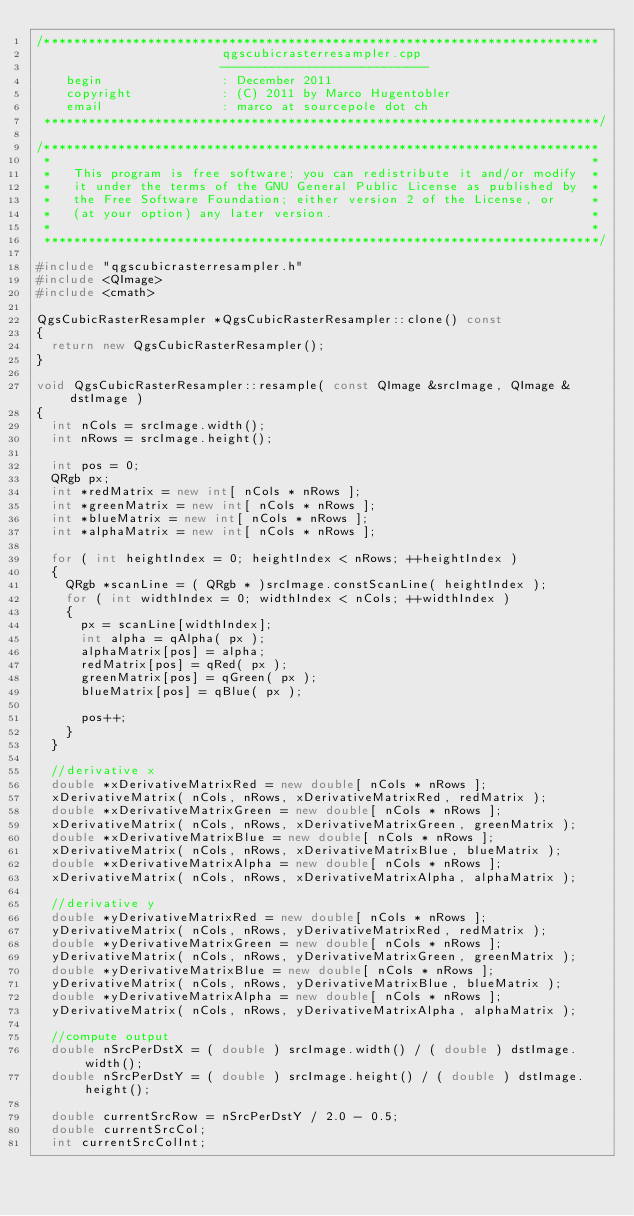Convert code to text. <code><loc_0><loc_0><loc_500><loc_500><_C++_>/***************************************************************************
                         qgscubicrasterresampler.cpp
                         ----------------------------
    begin                : December 2011
    copyright            : (C) 2011 by Marco Hugentobler
    email                : marco at sourcepole dot ch
 ***************************************************************************/

/***************************************************************************
 *                                                                         *
 *   This program is free software; you can redistribute it and/or modify  *
 *   it under the terms of the GNU General Public License as published by  *
 *   the Free Software Foundation; either version 2 of the License, or     *
 *   (at your option) any later version.                                   *
 *                                                                         *
 ***************************************************************************/

#include "qgscubicrasterresampler.h"
#include <QImage>
#include <cmath>

QgsCubicRasterResampler *QgsCubicRasterResampler::clone() const
{
  return new QgsCubicRasterResampler();
}

void QgsCubicRasterResampler::resample( const QImage &srcImage, QImage &dstImage )
{
  int nCols = srcImage.width();
  int nRows = srcImage.height();

  int pos = 0;
  QRgb px;
  int *redMatrix = new int[ nCols * nRows ];
  int *greenMatrix = new int[ nCols * nRows ];
  int *blueMatrix = new int[ nCols * nRows ];
  int *alphaMatrix = new int[ nCols * nRows ];

  for ( int heightIndex = 0; heightIndex < nRows; ++heightIndex )
  {
    QRgb *scanLine = ( QRgb * )srcImage.constScanLine( heightIndex );
    for ( int widthIndex = 0; widthIndex < nCols; ++widthIndex )
    {
      px = scanLine[widthIndex];
      int alpha = qAlpha( px );
      alphaMatrix[pos] = alpha;
      redMatrix[pos] = qRed( px );
      greenMatrix[pos] = qGreen( px );
      blueMatrix[pos] = qBlue( px );

      pos++;
    }
  }

  //derivative x
  double *xDerivativeMatrixRed = new double[ nCols * nRows ];
  xDerivativeMatrix( nCols, nRows, xDerivativeMatrixRed, redMatrix );
  double *xDerivativeMatrixGreen = new double[ nCols * nRows ];
  xDerivativeMatrix( nCols, nRows, xDerivativeMatrixGreen, greenMatrix );
  double *xDerivativeMatrixBlue = new double[ nCols * nRows ];
  xDerivativeMatrix( nCols, nRows, xDerivativeMatrixBlue, blueMatrix );
  double *xDerivativeMatrixAlpha = new double[ nCols * nRows ];
  xDerivativeMatrix( nCols, nRows, xDerivativeMatrixAlpha, alphaMatrix );

  //derivative y
  double *yDerivativeMatrixRed = new double[ nCols * nRows ];
  yDerivativeMatrix( nCols, nRows, yDerivativeMatrixRed, redMatrix );
  double *yDerivativeMatrixGreen = new double[ nCols * nRows ];
  yDerivativeMatrix( nCols, nRows, yDerivativeMatrixGreen, greenMatrix );
  double *yDerivativeMatrixBlue = new double[ nCols * nRows ];
  yDerivativeMatrix( nCols, nRows, yDerivativeMatrixBlue, blueMatrix );
  double *yDerivativeMatrixAlpha = new double[ nCols * nRows ];
  yDerivativeMatrix( nCols, nRows, yDerivativeMatrixAlpha, alphaMatrix );

  //compute output
  double nSrcPerDstX = ( double ) srcImage.width() / ( double ) dstImage.width();
  double nSrcPerDstY = ( double ) srcImage.height() / ( double ) dstImage.height();

  double currentSrcRow = nSrcPerDstY / 2.0 - 0.5;
  double currentSrcCol;
  int currentSrcColInt;</code> 